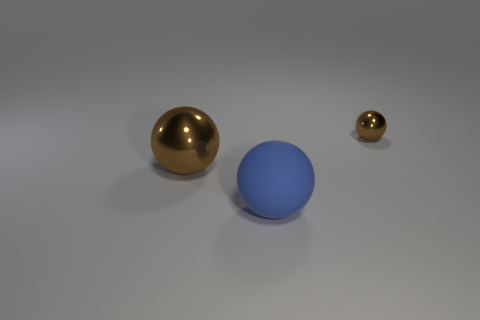Are there any other things that are the same material as the large blue thing?
Keep it short and to the point. No. There is a thing that is the same color as the big metal sphere; what is its shape?
Provide a succinct answer. Sphere. There is a large brown metallic ball left of the brown object that is right of the blue ball; is there a small metal sphere left of it?
Give a very brief answer. No. Are there the same number of brown things in front of the tiny brown ball and rubber spheres that are on the right side of the blue rubber sphere?
Ensure brevity in your answer.  No. There is a metallic thing that is in front of the small brown thing; what shape is it?
Your response must be concise. Sphere. There is a brown thing that is the same size as the blue matte object; what is its shape?
Provide a succinct answer. Sphere. What is the color of the thing behind the brown object in front of the brown metal sphere to the right of the large rubber object?
Provide a short and direct response. Brown. Is the tiny object the same shape as the big shiny thing?
Ensure brevity in your answer.  Yes. Are there the same number of brown spheres that are to the left of the small brown thing and brown balls?
Provide a succinct answer. No. How many other things are there of the same material as the large brown object?
Make the answer very short. 1. 